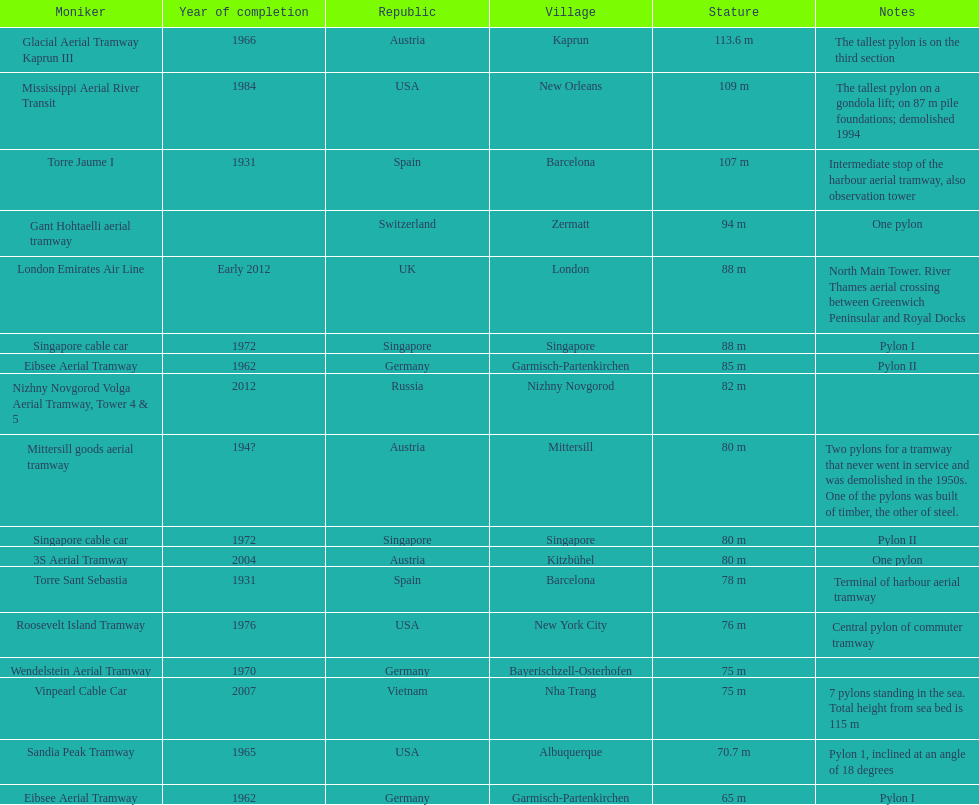Which pylon is the least tall? Eibsee Aerial Tramway. I'm looking to parse the entire table for insights. Could you assist me with that? {'header': ['Moniker', 'Year of completion', 'Republic', 'Village', 'Stature', 'Notes'], 'rows': [['Glacial Aerial Tramway Kaprun III', '1966', 'Austria', 'Kaprun', '113.6 m', 'The tallest pylon is on the third section'], ['Mississippi Aerial River Transit', '1984', 'USA', 'New Orleans', '109 m', 'The tallest pylon on a gondola lift; on 87 m pile foundations; demolished 1994'], ['Torre Jaume I', '1931', 'Spain', 'Barcelona', '107 m', 'Intermediate stop of the harbour aerial tramway, also observation tower'], ['Gant Hohtaelli aerial tramway', '', 'Switzerland', 'Zermatt', '94 m', 'One pylon'], ['London Emirates Air Line', 'Early 2012', 'UK', 'London', '88 m', 'North Main Tower. River Thames aerial crossing between Greenwich Peninsular and Royal Docks'], ['Singapore cable car', '1972', 'Singapore', 'Singapore', '88 m', 'Pylon I'], ['Eibsee Aerial Tramway', '1962', 'Germany', 'Garmisch-Partenkirchen', '85 m', 'Pylon II'], ['Nizhny Novgorod Volga Aerial Tramway, Tower 4 & 5', '2012', 'Russia', 'Nizhny Novgorod', '82 m', ''], ['Mittersill goods aerial tramway', '194?', 'Austria', 'Mittersill', '80 m', 'Two pylons for a tramway that never went in service and was demolished in the 1950s. One of the pylons was built of timber, the other of steel.'], ['Singapore cable car', '1972', 'Singapore', 'Singapore', '80 m', 'Pylon II'], ['3S Aerial Tramway', '2004', 'Austria', 'Kitzbühel', '80 m', 'One pylon'], ['Torre Sant Sebastia', '1931', 'Spain', 'Barcelona', '78 m', 'Terminal of harbour aerial tramway'], ['Roosevelt Island Tramway', '1976', 'USA', 'New York City', '76 m', 'Central pylon of commuter tramway'], ['Wendelstein Aerial Tramway', '1970', 'Germany', 'Bayerischzell-Osterhofen', '75 m', ''], ['Vinpearl Cable Car', '2007', 'Vietnam', 'Nha Trang', '75 m', '7 pylons standing in the sea. Total height from sea bed is 115 m'], ['Sandia Peak Tramway', '1965', 'USA', 'Albuquerque', '70.7 m', 'Pylon 1, inclined at an angle of 18 degrees'], ['Eibsee Aerial Tramway', '1962', 'Germany', 'Garmisch-Partenkirchen', '65 m', 'Pylon I']]} 